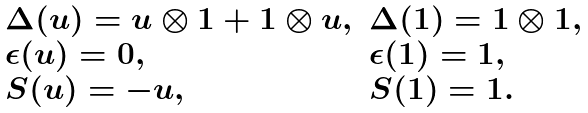<formula> <loc_0><loc_0><loc_500><loc_500>\begin{array} { l l } \Delta ( u ) = u \otimes 1 + 1 \otimes u , & \Delta ( 1 ) = 1 \otimes 1 , \\ \epsilon ( u ) = 0 , & \epsilon ( 1 ) = 1 , \\ S ( u ) = - u , & S ( 1 ) = 1 . \end{array}</formula> 